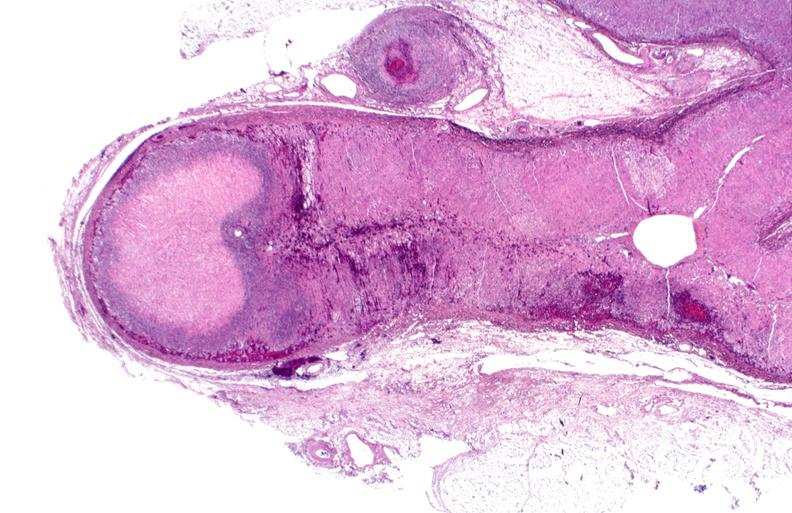does this image show adrenal, polyarteritis nodosa with infarct?
Answer the question using a single word or phrase. Yes 